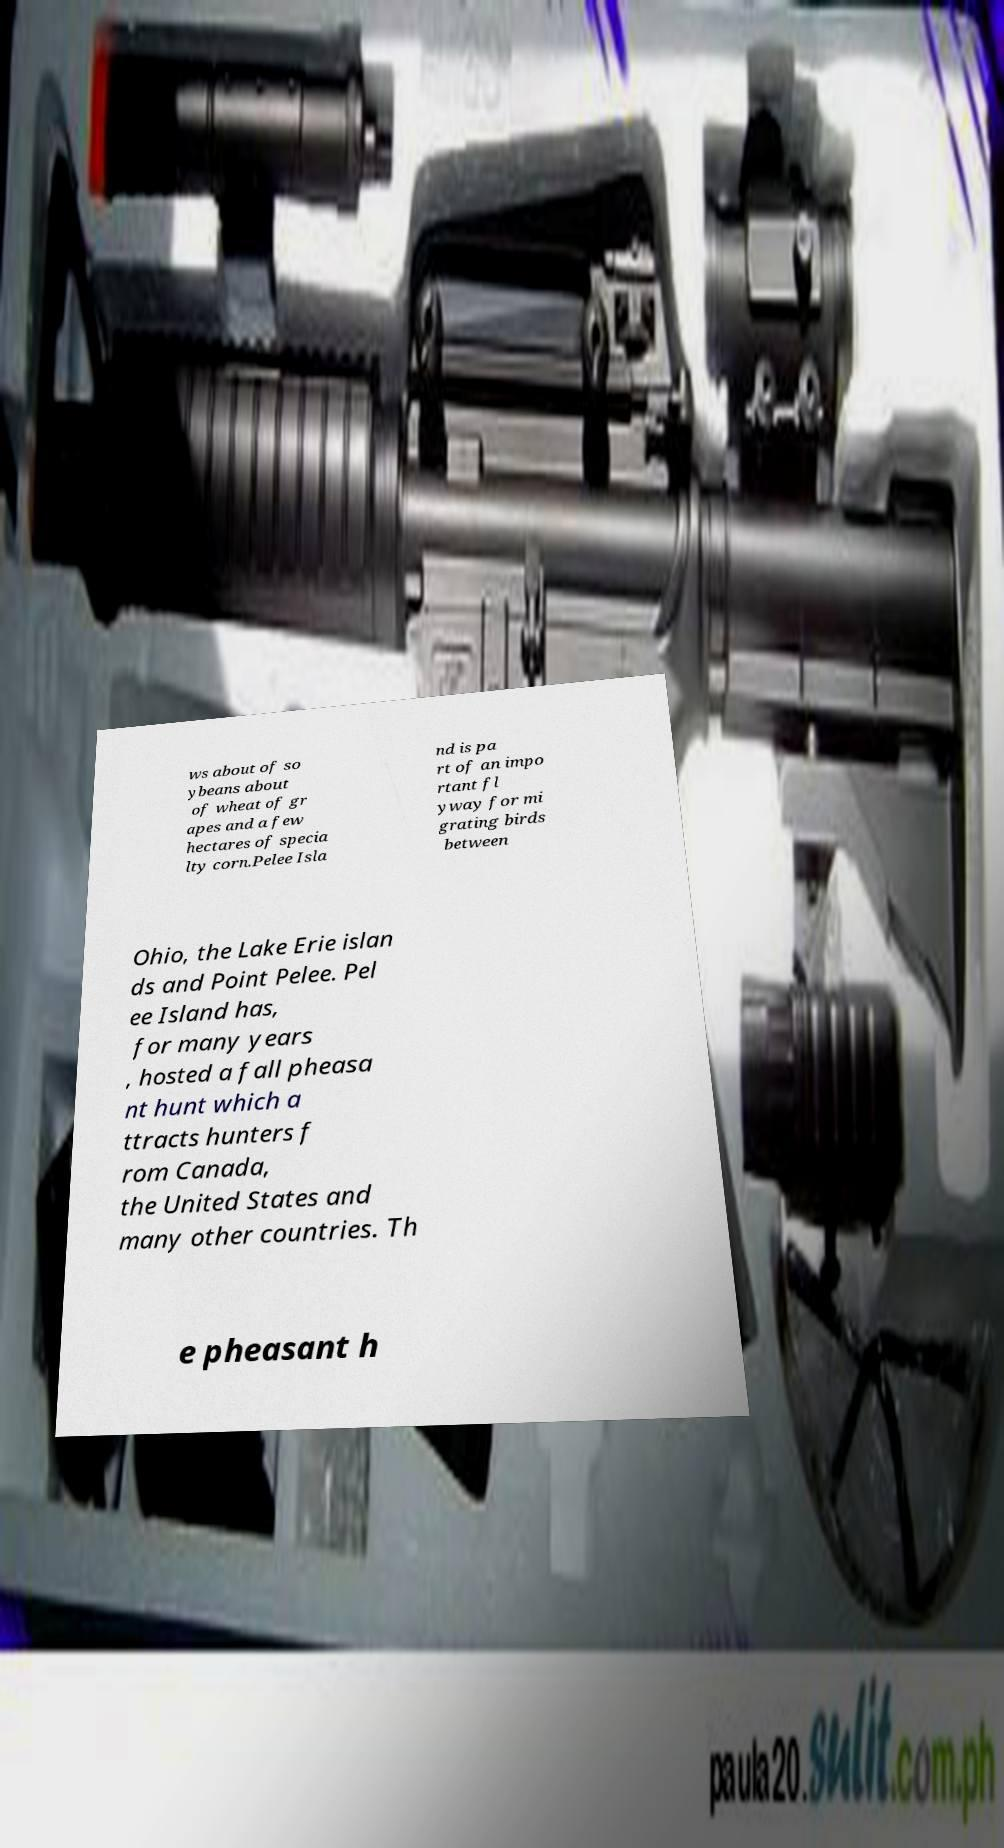Could you assist in decoding the text presented in this image and type it out clearly? ws about of so ybeans about of wheat of gr apes and a few hectares of specia lty corn.Pelee Isla nd is pa rt of an impo rtant fl yway for mi grating birds between Ohio, the Lake Erie islan ds and Point Pelee. Pel ee Island has, for many years , hosted a fall pheasa nt hunt which a ttracts hunters f rom Canada, the United States and many other countries. Th e pheasant h 